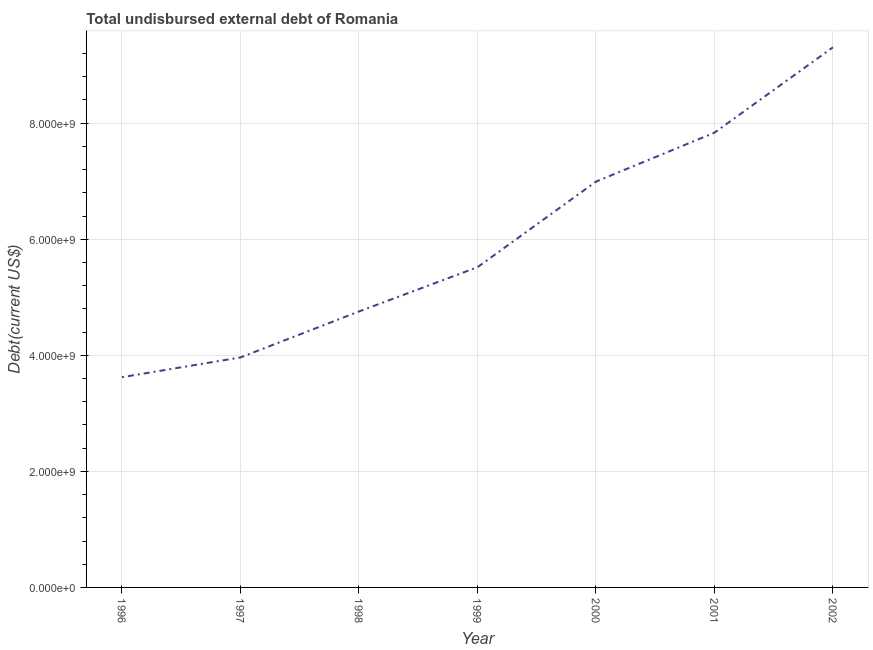What is the total debt in 2000?
Make the answer very short. 6.99e+09. Across all years, what is the maximum total debt?
Your response must be concise. 9.31e+09. Across all years, what is the minimum total debt?
Provide a succinct answer. 3.62e+09. What is the sum of the total debt?
Your answer should be compact. 4.20e+1. What is the difference between the total debt in 1996 and 1998?
Your answer should be very brief. -1.13e+09. What is the average total debt per year?
Your answer should be very brief. 6.00e+09. What is the median total debt?
Give a very brief answer. 5.52e+09. In how many years, is the total debt greater than 7200000000 US$?
Ensure brevity in your answer.  2. Do a majority of the years between 1997 and 2002 (inclusive) have total debt greater than 2800000000 US$?
Provide a succinct answer. Yes. What is the ratio of the total debt in 1998 to that in 1999?
Keep it short and to the point. 0.86. What is the difference between the highest and the second highest total debt?
Offer a very short reply. 1.47e+09. Is the sum of the total debt in 2000 and 2002 greater than the maximum total debt across all years?
Give a very brief answer. Yes. What is the difference between the highest and the lowest total debt?
Your answer should be very brief. 5.68e+09. How many lines are there?
Your answer should be very brief. 1. Are the values on the major ticks of Y-axis written in scientific E-notation?
Your answer should be very brief. Yes. What is the title of the graph?
Keep it short and to the point. Total undisbursed external debt of Romania. What is the label or title of the X-axis?
Your answer should be compact. Year. What is the label or title of the Y-axis?
Offer a terse response. Debt(current US$). What is the Debt(current US$) of 1996?
Your response must be concise. 3.62e+09. What is the Debt(current US$) in 1997?
Provide a short and direct response. 3.96e+09. What is the Debt(current US$) in 1998?
Keep it short and to the point. 4.76e+09. What is the Debt(current US$) in 1999?
Offer a terse response. 5.52e+09. What is the Debt(current US$) of 2000?
Your answer should be very brief. 6.99e+09. What is the Debt(current US$) of 2001?
Your response must be concise. 7.84e+09. What is the Debt(current US$) in 2002?
Your answer should be very brief. 9.31e+09. What is the difference between the Debt(current US$) in 1996 and 1997?
Give a very brief answer. -3.40e+08. What is the difference between the Debt(current US$) in 1996 and 1998?
Your answer should be very brief. -1.13e+09. What is the difference between the Debt(current US$) in 1996 and 1999?
Ensure brevity in your answer.  -1.89e+09. What is the difference between the Debt(current US$) in 1996 and 2000?
Your response must be concise. -3.37e+09. What is the difference between the Debt(current US$) in 1996 and 2001?
Ensure brevity in your answer.  -4.21e+09. What is the difference between the Debt(current US$) in 1996 and 2002?
Your answer should be very brief. -5.68e+09. What is the difference between the Debt(current US$) in 1997 and 1998?
Offer a very short reply. -7.92e+08. What is the difference between the Debt(current US$) in 1997 and 1999?
Your answer should be compact. -1.55e+09. What is the difference between the Debt(current US$) in 1997 and 2000?
Your answer should be compact. -3.03e+09. What is the difference between the Debt(current US$) in 1997 and 2001?
Offer a very short reply. -3.87e+09. What is the difference between the Debt(current US$) in 1997 and 2002?
Offer a terse response. -5.34e+09. What is the difference between the Debt(current US$) in 1998 and 1999?
Keep it short and to the point. -7.63e+08. What is the difference between the Debt(current US$) in 1998 and 2000?
Provide a succinct answer. -2.24e+09. What is the difference between the Debt(current US$) in 1998 and 2001?
Your response must be concise. -3.08e+09. What is the difference between the Debt(current US$) in 1998 and 2002?
Make the answer very short. -4.55e+09. What is the difference between the Debt(current US$) in 1999 and 2000?
Provide a short and direct response. -1.48e+09. What is the difference between the Debt(current US$) in 1999 and 2001?
Provide a succinct answer. -2.32e+09. What is the difference between the Debt(current US$) in 1999 and 2002?
Provide a succinct answer. -3.79e+09. What is the difference between the Debt(current US$) in 2000 and 2001?
Provide a succinct answer. -8.44e+08. What is the difference between the Debt(current US$) in 2000 and 2002?
Your response must be concise. -2.31e+09. What is the difference between the Debt(current US$) in 2001 and 2002?
Ensure brevity in your answer.  -1.47e+09. What is the ratio of the Debt(current US$) in 1996 to that in 1997?
Your response must be concise. 0.91. What is the ratio of the Debt(current US$) in 1996 to that in 1998?
Give a very brief answer. 0.76. What is the ratio of the Debt(current US$) in 1996 to that in 1999?
Offer a terse response. 0.66. What is the ratio of the Debt(current US$) in 1996 to that in 2000?
Your response must be concise. 0.52. What is the ratio of the Debt(current US$) in 1996 to that in 2001?
Give a very brief answer. 0.46. What is the ratio of the Debt(current US$) in 1996 to that in 2002?
Your response must be concise. 0.39. What is the ratio of the Debt(current US$) in 1997 to that in 1998?
Offer a very short reply. 0.83. What is the ratio of the Debt(current US$) in 1997 to that in 1999?
Give a very brief answer. 0.72. What is the ratio of the Debt(current US$) in 1997 to that in 2000?
Your response must be concise. 0.57. What is the ratio of the Debt(current US$) in 1997 to that in 2001?
Your answer should be compact. 0.51. What is the ratio of the Debt(current US$) in 1997 to that in 2002?
Keep it short and to the point. 0.43. What is the ratio of the Debt(current US$) in 1998 to that in 1999?
Provide a short and direct response. 0.86. What is the ratio of the Debt(current US$) in 1998 to that in 2000?
Offer a terse response. 0.68. What is the ratio of the Debt(current US$) in 1998 to that in 2001?
Provide a succinct answer. 0.61. What is the ratio of the Debt(current US$) in 1998 to that in 2002?
Your response must be concise. 0.51. What is the ratio of the Debt(current US$) in 1999 to that in 2000?
Provide a short and direct response. 0.79. What is the ratio of the Debt(current US$) in 1999 to that in 2001?
Ensure brevity in your answer.  0.7. What is the ratio of the Debt(current US$) in 1999 to that in 2002?
Your answer should be very brief. 0.59. What is the ratio of the Debt(current US$) in 2000 to that in 2001?
Provide a succinct answer. 0.89. What is the ratio of the Debt(current US$) in 2000 to that in 2002?
Your response must be concise. 0.75. What is the ratio of the Debt(current US$) in 2001 to that in 2002?
Your answer should be very brief. 0.84. 